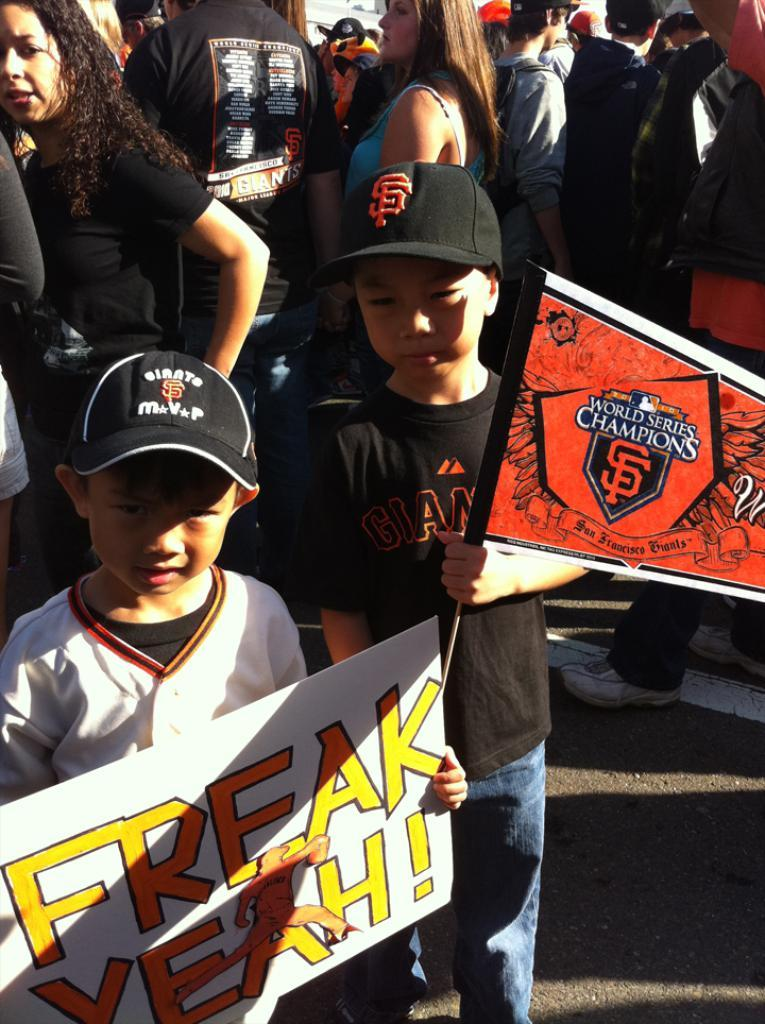<image>
Provide a brief description of the given image. Two young boys at a baseball game one holding a World Champions pin and one holding a sign. 